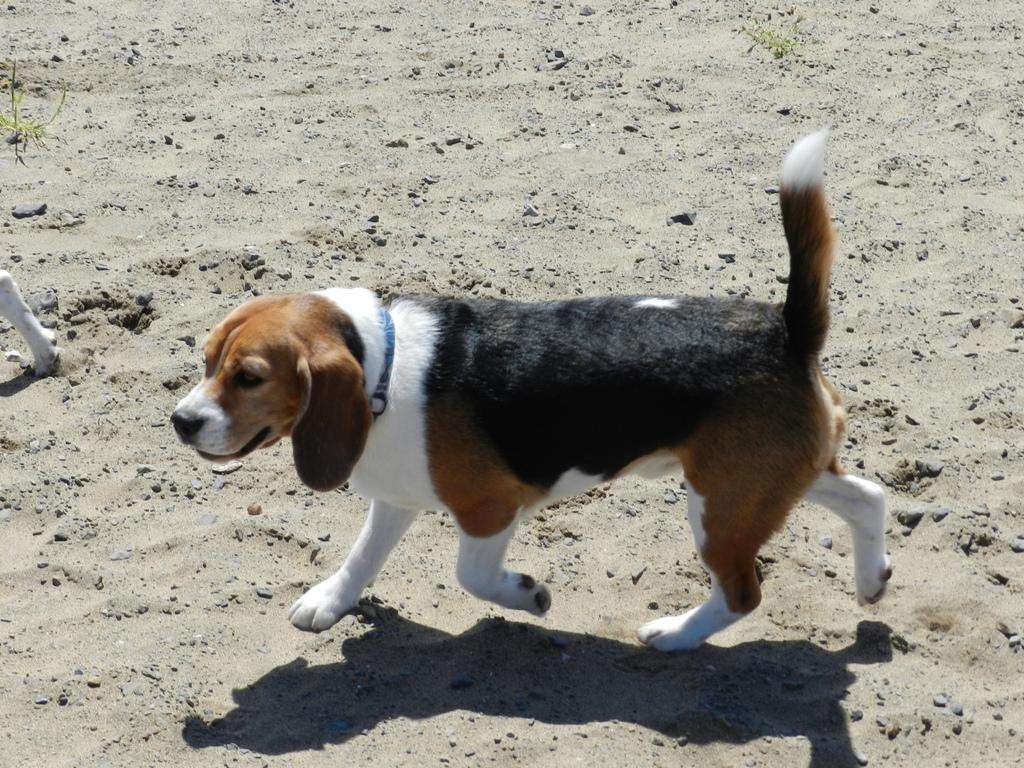What type of animal is present in the image? There is a dog in the image. What can be seen on the ground in the image? There are small stones on the ground in the image. What type of terrain is visible in the image? There is sand in the image. What type of prison can be seen in the background of the image? There is no prison present in the image; it features a dog and a sandy terrain with small stones on the ground. 